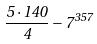<formula> <loc_0><loc_0><loc_500><loc_500>\frac { 5 \cdot 1 4 0 } { 4 } - 7 ^ { 3 5 7 }</formula> 